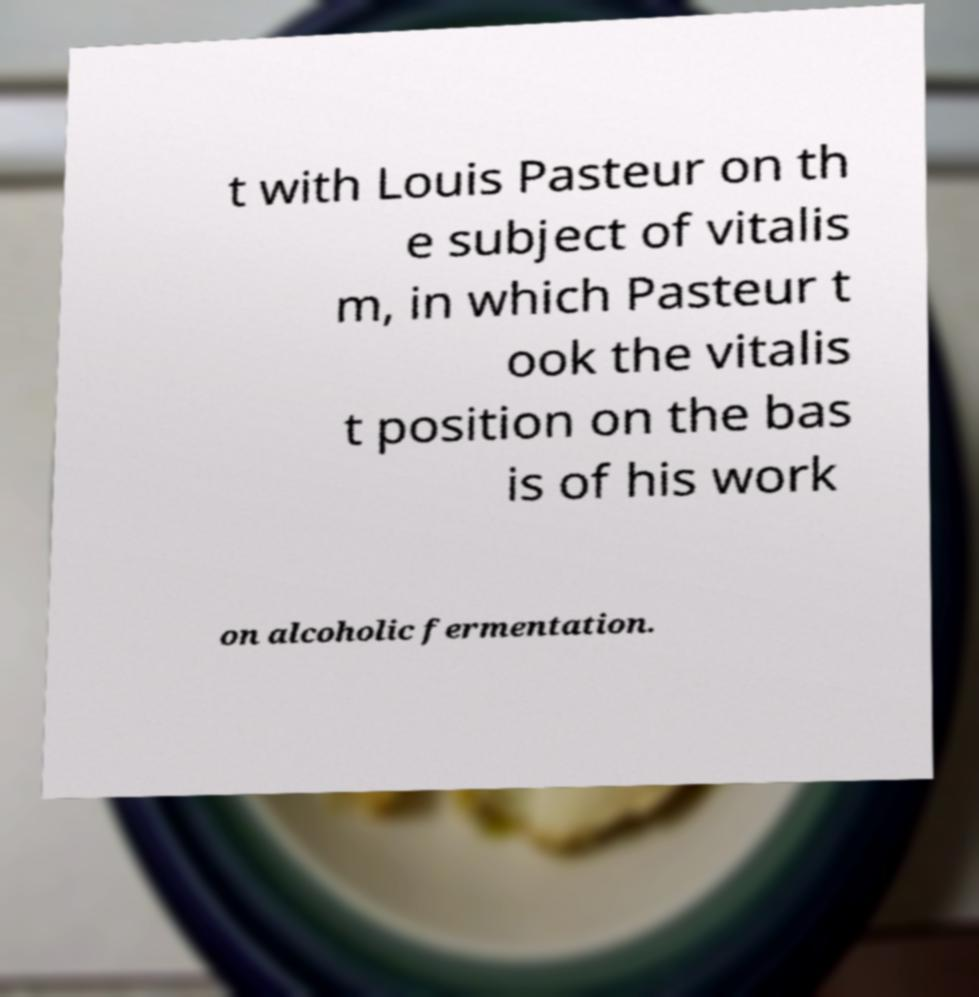Please identify and transcribe the text found in this image. t with Louis Pasteur on th e subject of vitalis m, in which Pasteur t ook the vitalis t position on the bas is of his work on alcoholic fermentation. 